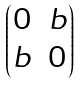Convert formula to latex. <formula><loc_0><loc_0><loc_500><loc_500>\begin{pmatrix} 0 & b \\ b & 0 \end{pmatrix}</formula> 